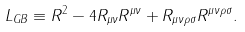Convert formula to latex. <formula><loc_0><loc_0><loc_500><loc_500>L _ { G B } \equiv R ^ { 2 } - 4 R _ { \mu \nu } R ^ { \mu \nu } + R _ { \mu \nu \rho \sigma } R ^ { \mu \nu \rho \sigma } .</formula> 